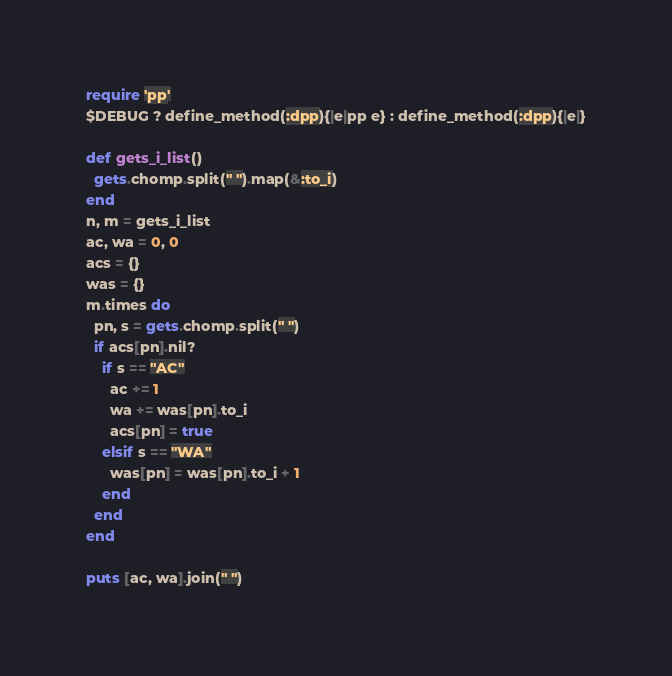Convert code to text. <code><loc_0><loc_0><loc_500><loc_500><_Ruby_>require 'pp'
$DEBUG ? define_method(:dpp){|e|pp e} : define_method(:dpp){|e|}

def gets_i_list()
  gets.chomp.split(" ").map(&:to_i)
end
n, m = gets_i_list
ac, wa = 0, 0
acs = {}
was = {}
m.times do
  pn, s = gets.chomp.split(" ")
  if acs[pn].nil?
    if s == "AC"
      ac += 1
      wa += was[pn].to_i
      acs[pn] = true
    elsif s == "WA"
      was[pn] = was[pn].to_i + 1
    end
  end
end

puts [ac, wa].join(" ")</code> 